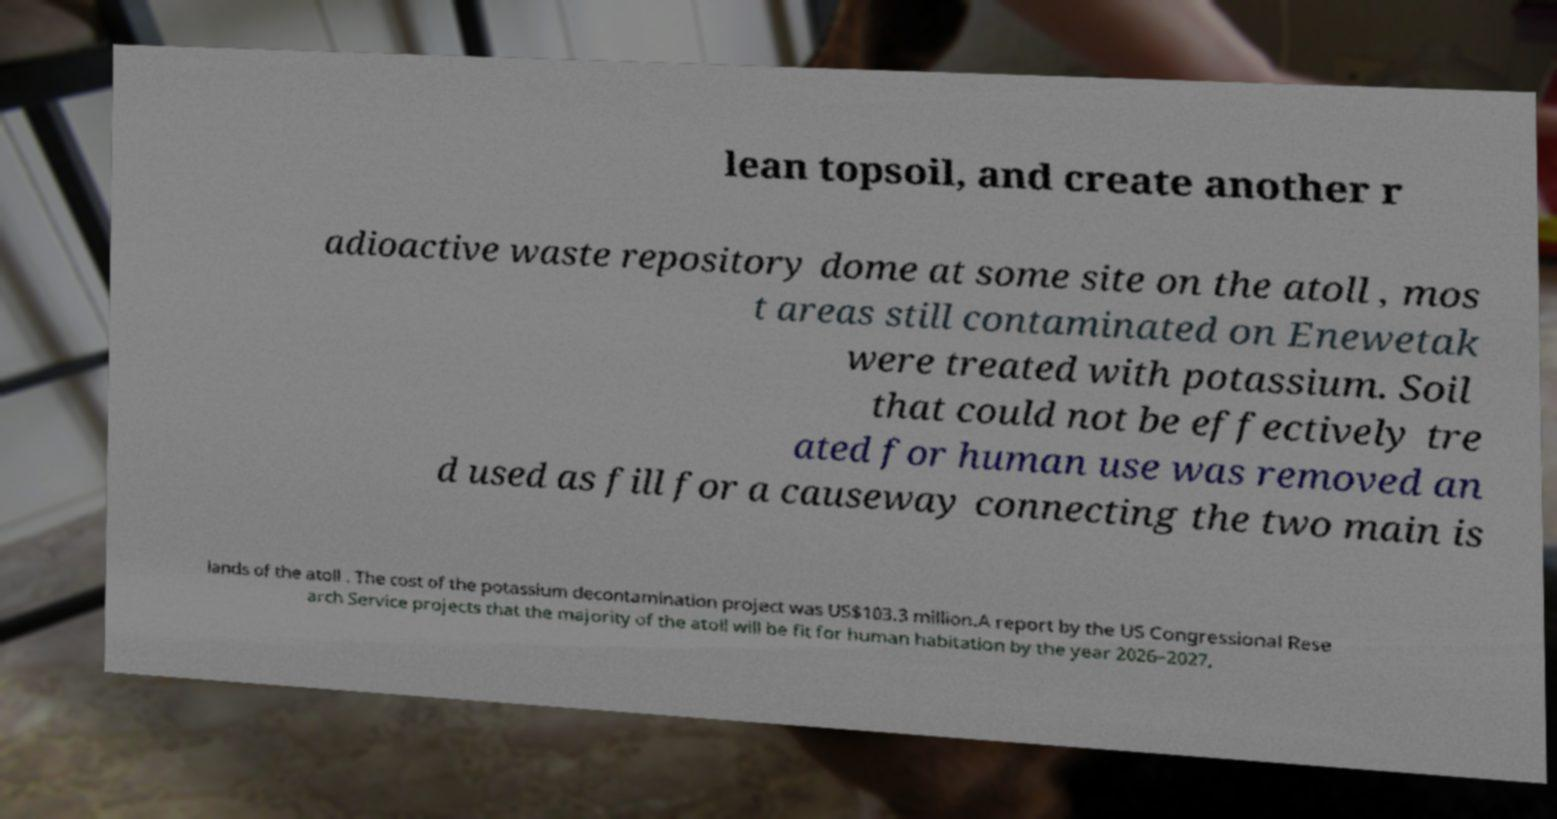Can you accurately transcribe the text from the provided image for me? lean topsoil, and create another r adioactive waste repository dome at some site on the atoll , mos t areas still contaminated on Enewetak were treated with potassium. Soil that could not be effectively tre ated for human use was removed an d used as fill for a causeway connecting the two main is lands of the atoll . The cost of the potassium decontamination project was US$103.3 million.A report by the US Congressional Rese arch Service projects that the majority of the atoll will be fit for human habitation by the year 2026–2027, 